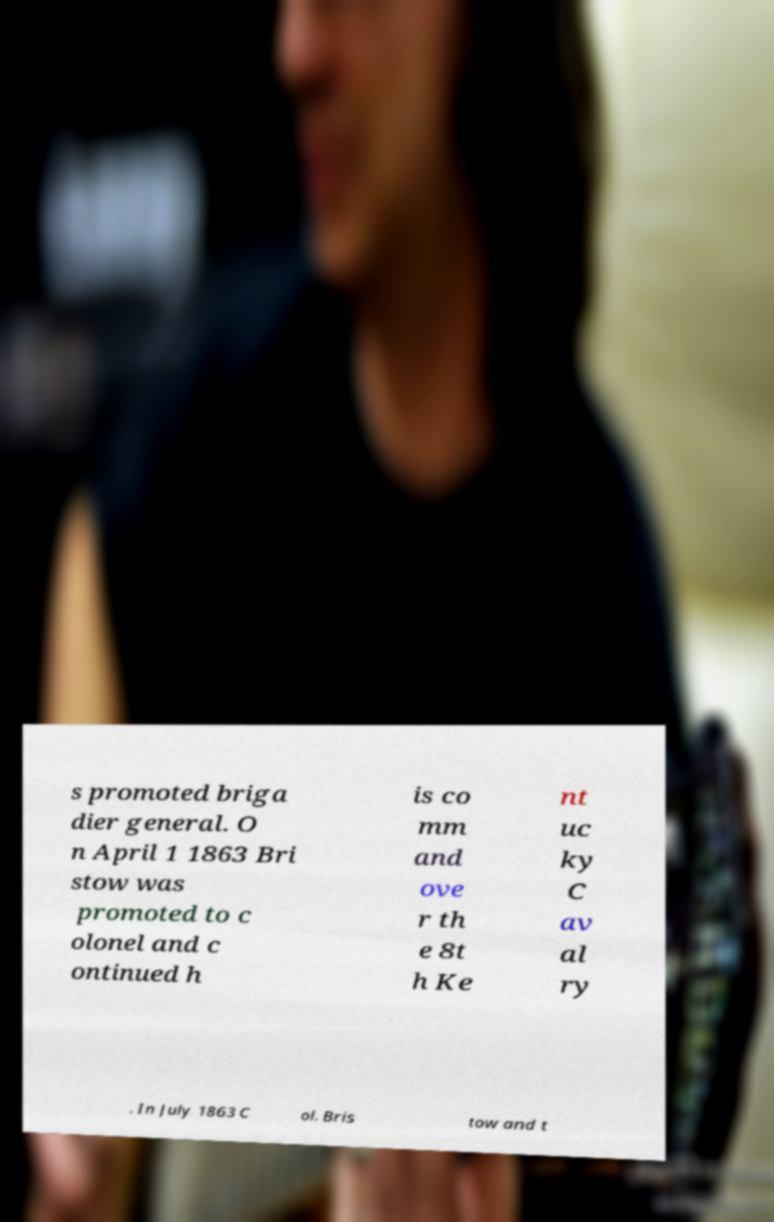Can you read and provide the text displayed in the image?This photo seems to have some interesting text. Can you extract and type it out for me? s promoted briga dier general. O n April 1 1863 Bri stow was promoted to c olonel and c ontinued h is co mm and ove r th e 8t h Ke nt uc ky C av al ry . In July 1863 C ol. Bris tow and t 